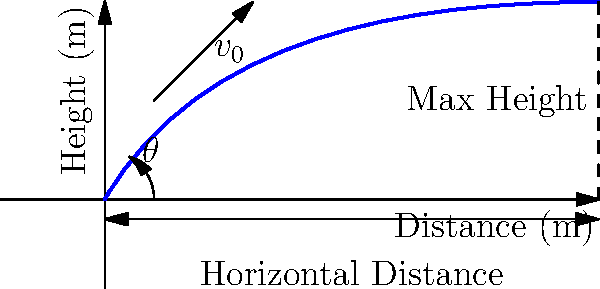As you practice your curved shots, you want to calculate the velocity of the ball at its highest point. If you kick the ball with an initial velocity ($v_0$) of 25 m/s at an angle ($\theta$) of 60° to the horizontal, what is the velocity of the ball at its maximum height? Assume no air resistance and use $g = 9.8$ m/s². To solve this problem, let's break it down into steps:

1) First, we need to understand that at the highest point, the vertical component of velocity is zero.

2) The horizontal component of velocity remains constant throughout the trajectory (assuming no air resistance).

3) We can find the horizontal component of the initial velocity:
   $v_x = v_0 \cos(\theta) = 25 \cos(60°) = 12.5$ m/s

4) This horizontal velocity remains constant, so it's the same at the highest point.

5) The velocity at the highest point is equal to the horizontal component, as the vertical component is zero.

6) Therefore, the velocity at the highest point is 12.5 m/s.

7) We can verify this using the Pythagorean theorem:
   $v = \sqrt{v_x^2 + v_y^2} = \sqrt{12.5^2 + 0^2} = 12.5$ m/s

This calculation helps you understand how the ball's speed changes during its flight, which is crucial for mastering curved shots in football.
Answer: 12.5 m/s 